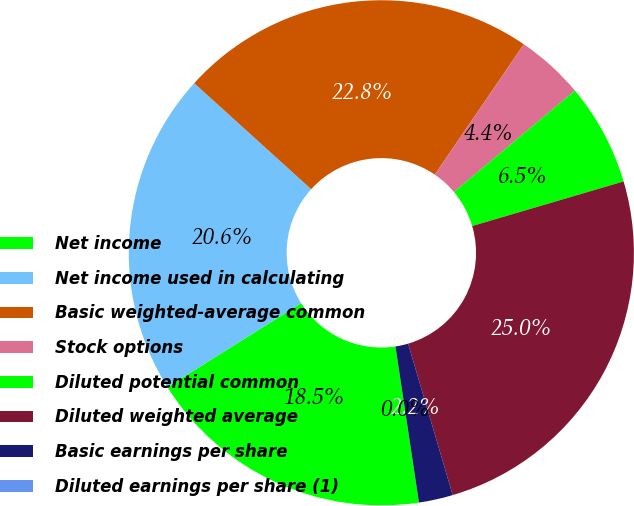<chart> <loc_0><loc_0><loc_500><loc_500><pie_chart><fcel>Net income<fcel>Net income used in calculating<fcel>Basic weighted-average common<fcel>Stock options<fcel>Diluted potential common<fcel>Diluted weighted average<fcel>Basic earnings per share<fcel>Diluted earnings per share (1)<nl><fcel>18.46%<fcel>20.64%<fcel>22.82%<fcel>4.36%<fcel>6.54%<fcel>25.0%<fcel>2.18%<fcel>0.0%<nl></chart> 